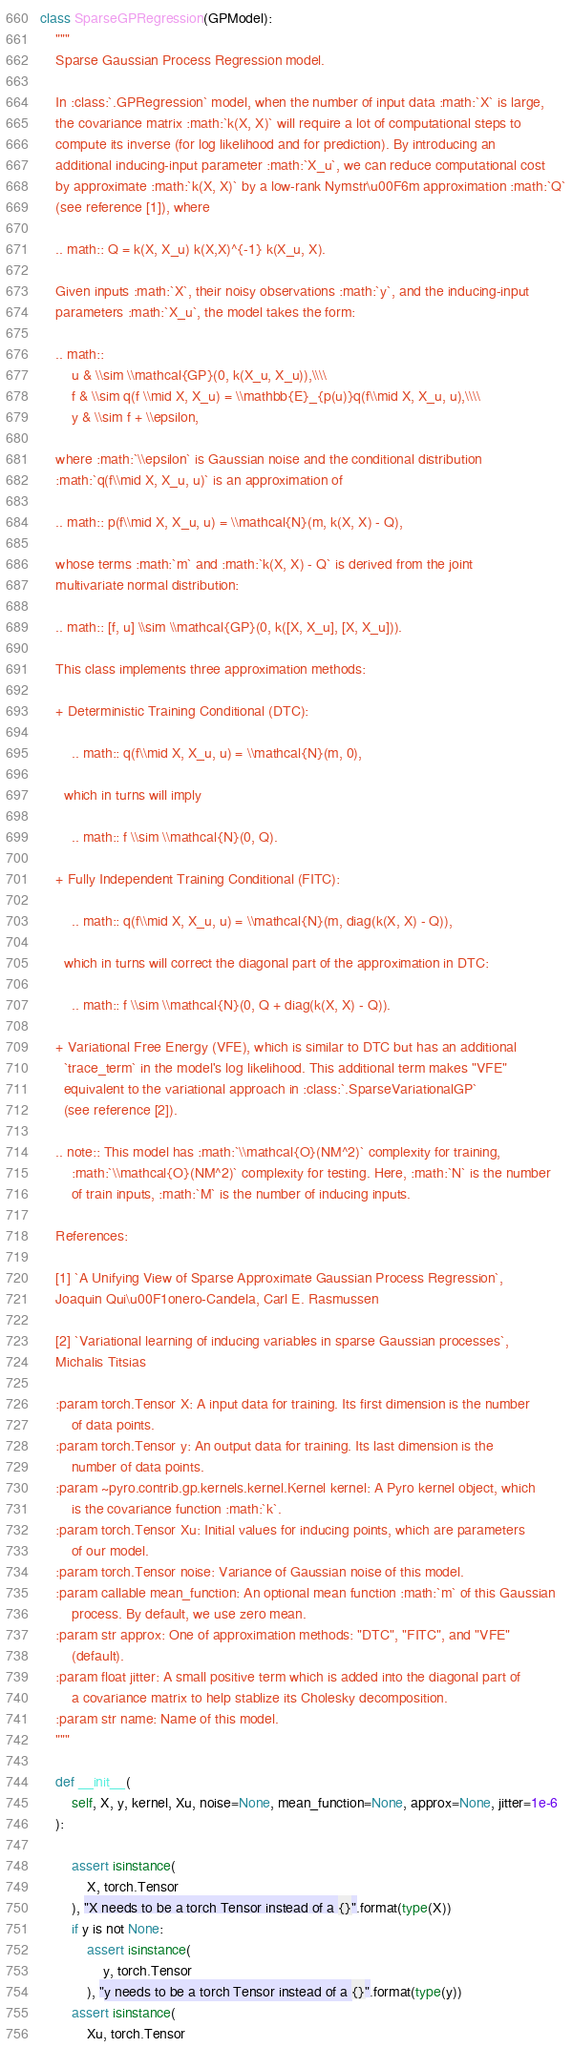Convert code to text. <code><loc_0><loc_0><loc_500><loc_500><_Python_>
class SparseGPRegression(GPModel):
    """
    Sparse Gaussian Process Regression model.

    In :class:`.GPRegression` model, when the number of input data :math:`X` is large,
    the covariance matrix :math:`k(X, X)` will require a lot of computational steps to
    compute its inverse (for log likelihood and for prediction). By introducing an
    additional inducing-input parameter :math:`X_u`, we can reduce computational cost
    by approximate :math:`k(X, X)` by a low-rank Nymstr\u00F6m approximation :math:`Q`
    (see reference [1]), where

    .. math:: Q = k(X, X_u) k(X,X)^{-1} k(X_u, X).

    Given inputs :math:`X`, their noisy observations :math:`y`, and the inducing-input
    parameters :math:`X_u`, the model takes the form:

    .. math::
        u & \\sim \\mathcal{GP}(0, k(X_u, X_u)),\\\\
        f & \\sim q(f \\mid X, X_u) = \\mathbb{E}_{p(u)}q(f\\mid X, X_u, u),\\\\
        y & \\sim f + \\epsilon,

    where :math:`\\epsilon` is Gaussian noise and the conditional distribution
    :math:`q(f\\mid X, X_u, u)` is an approximation of

    .. math:: p(f\\mid X, X_u, u) = \\mathcal{N}(m, k(X, X) - Q),

    whose terms :math:`m` and :math:`k(X, X) - Q` is derived from the joint
    multivariate normal distribution:

    .. math:: [f, u] \\sim \\mathcal{GP}(0, k([X, X_u], [X, X_u])).

    This class implements three approximation methods:

    + Deterministic Training Conditional (DTC):

        .. math:: q(f\\mid X, X_u, u) = \\mathcal{N}(m, 0),

      which in turns will imply

        .. math:: f \\sim \\mathcal{N}(0, Q).

    + Fully Independent Training Conditional (FITC):

        .. math:: q(f\\mid X, X_u, u) = \\mathcal{N}(m, diag(k(X, X) - Q)),

      which in turns will correct the diagonal part of the approximation in DTC:

        .. math:: f \\sim \\mathcal{N}(0, Q + diag(k(X, X) - Q)).

    + Variational Free Energy (VFE), which is similar to DTC but has an additional
      `trace_term` in the model's log likelihood. This additional term makes "VFE"
      equivalent to the variational approach in :class:`.SparseVariationalGP`
      (see reference [2]).

    .. note:: This model has :math:`\\mathcal{O}(NM^2)` complexity for training,
        :math:`\\mathcal{O}(NM^2)` complexity for testing. Here, :math:`N` is the number
        of train inputs, :math:`M` is the number of inducing inputs.

    References:

    [1] `A Unifying View of Sparse Approximate Gaussian Process Regression`,
    Joaquin Qui\u00F1onero-Candela, Carl E. Rasmussen

    [2] `Variational learning of inducing variables in sparse Gaussian processes`,
    Michalis Titsias

    :param torch.Tensor X: A input data for training. Its first dimension is the number
        of data points.
    :param torch.Tensor y: An output data for training. Its last dimension is the
        number of data points.
    :param ~pyro.contrib.gp.kernels.kernel.Kernel kernel: A Pyro kernel object, which
        is the covariance function :math:`k`.
    :param torch.Tensor Xu: Initial values for inducing points, which are parameters
        of our model.
    :param torch.Tensor noise: Variance of Gaussian noise of this model.
    :param callable mean_function: An optional mean function :math:`m` of this Gaussian
        process. By default, we use zero mean.
    :param str approx: One of approximation methods: "DTC", "FITC", and "VFE"
        (default).
    :param float jitter: A small positive term which is added into the diagonal part of
        a covariance matrix to help stablize its Cholesky decomposition.
    :param str name: Name of this model.
    """

    def __init__(
        self, X, y, kernel, Xu, noise=None, mean_function=None, approx=None, jitter=1e-6
    ):

        assert isinstance(
            X, torch.Tensor
        ), "X needs to be a torch Tensor instead of a {}".format(type(X))
        if y is not None:
            assert isinstance(
                y, torch.Tensor
            ), "y needs to be a torch Tensor instead of a {}".format(type(y))
        assert isinstance(
            Xu, torch.Tensor</code> 